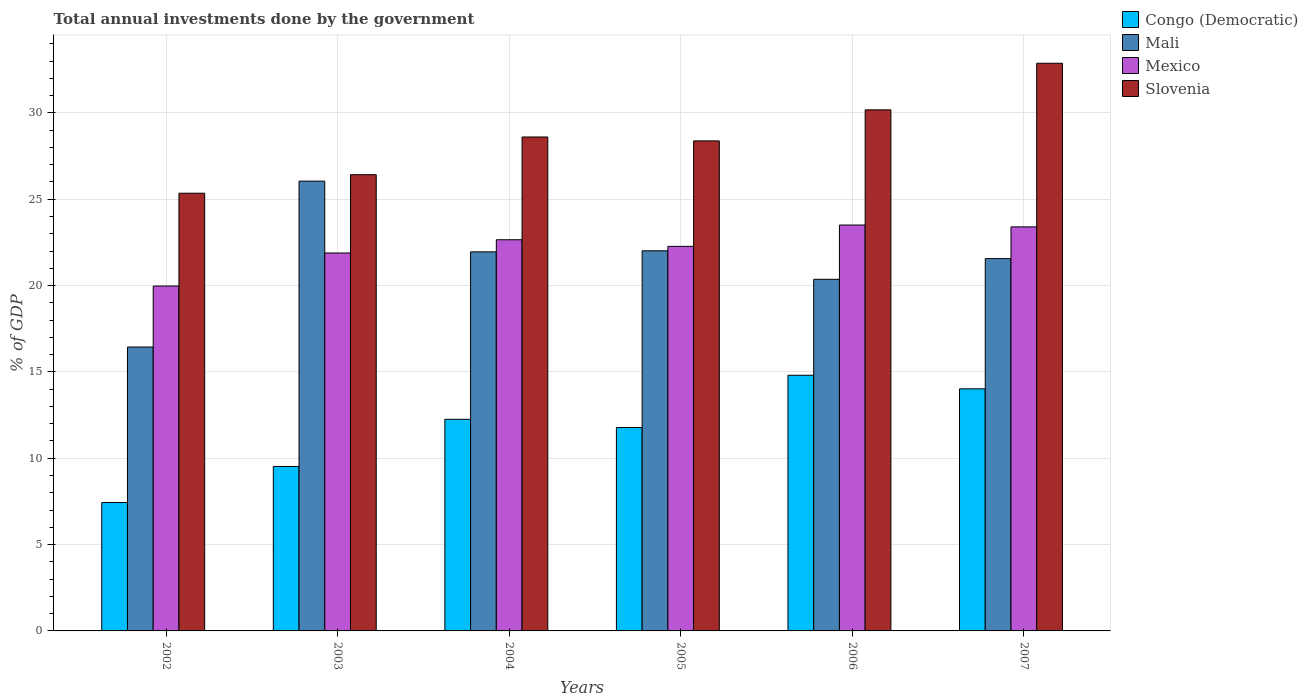Are the number of bars per tick equal to the number of legend labels?
Provide a succinct answer. Yes. How many bars are there on the 4th tick from the left?
Provide a succinct answer. 4. How many bars are there on the 4th tick from the right?
Offer a very short reply. 4. What is the total annual investments done by the government in Mali in 2005?
Keep it short and to the point. 22.01. Across all years, what is the maximum total annual investments done by the government in Mali?
Ensure brevity in your answer.  26.05. Across all years, what is the minimum total annual investments done by the government in Slovenia?
Your answer should be compact. 25.35. In which year was the total annual investments done by the government in Mali maximum?
Provide a succinct answer. 2003. In which year was the total annual investments done by the government in Mali minimum?
Offer a terse response. 2002. What is the total total annual investments done by the government in Mali in the graph?
Keep it short and to the point. 128.38. What is the difference between the total annual investments done by the government in Mali in 2003 and that in 2006?
Make the answer very short. 5.69. What is the difference between the total annual investments done by the government in Slovenia in 2007 and the total annual investments done by the government in Mexico in 2003?
Offer a very short reply. 10.99. What is the average total annual investments done by the government in Mali per year?
Ensure brevity in your answer.  21.4. In the year 2004, what is the difference between the total annual investments done by the government in Mali and total annual investments done by the government in Mexico?
Give a very brief answer. -0.7. In how many years, is the total annual investments done by the government in Congo (Democratic) greater than 29 %?
Your answer should be very brief. 0. What is the ratio of the total annual investments done by the government in Congo (Democratic) in 2002 to that in 2007?
Provide a succinct answer. 0.53. Is the total annual investments done by the government in Mexico in 2006 less than that in 2007?
Provide a succinct answer. No. What is the difference between the highest and the second highest total annual investments done by the government in Congo (Democratic)?
Offer a very short reply. 0.79. What is the difference between the highest and the lowest total annual investments done by the government in Slovenia?
Your answer should be compact. 7.53. In how many years, is the total annual investments done by the government in Slovenia greater than the average total annual investments done by the government in Slovenia taken over all years?
Provide a succinct answer. 2. Is the sum of the total annual investments done by the government in Mexico in 2003 and 2005 greater than the maximum total annual investments done by the government in Slovenia across all years?
Provide a succinct answer. Yes. What does the 1st bar from the left in 2002 represents?
Give a very brief answer. Congo (Democratic). What does the 4th bar from the right in 2003 represents?
Provide a short and direct response. Congo (Democratic). How many bars are there?
Offer a very short reply. 24. What is the difference between two consecutive major ticks on the Y-axis?
Give a very brief answer. 5. Are the values on the major ticks of Y-axis written in scientific E-notation?
Provide a succinct answer. No. How many legend labels are there?
Offer a very short reply. 4. What is the title of the graph?
Give a very brief answer. Total annual investments done by the government. What is the label or title of the Y-axis?
Your answer should be compact. % of GDP. What is the % of GDP of Congo (Democratic) in 2002?
Your answer should be very brief. 7.44. What is the % of GDP of Mali in 2002?
Provide a short and direct response. 16.44. What is the % of GDP in Mexico in 2002?
Your answer should be compact. 19.97. What is the % of GDP in Slovenia in 2002?
Provide a succinct answer. 25.35. What is the % of GDP of Congo (Democratic) in 2003?
Ensure brevity in your answer.  9.52. What is the % of GDP in Mali in 2003?
Ensure brevity in your answer.  26.05. What is the % of GDP in Mexico in 2003?
Give a very brief answer. 21.89. What is the % of GDP of Slovenia in 2003?
Give a very brief answer. 26.42. What is the % of GDP of Congo (Democratic) in 2004?
Ensure brevity in your answer.  12.26. What is the % of GDP of Mali in 2004?
Offer a very short reply. 21.95. What is the % of GDP of Mexico in 2004?
Offer a very short reply. 22.66. What is the % of GDP of Slovenia in 2004?
Your answer should be compact. 28.61. What is the % of GDP in Congo (Democratic) in 2005?
Give a very brief answer. 11.78. What is the % of GDP in Mali in 2005?
Ensure brevity in your answer.  22.01. What is the % of GDP of Mexico in 2005?
Keep it short and to the point. 22.27. What is the % of GDP of Slovenia in 2005?
Ensure brevity in your answer.  28.38. What is the % of GDP in Congo (Democratic) in 2006?
Your response must be concise. 14.81. What is the % of GDP of Mali in 2006?
Make the answer very short. 20.36. What is the % of GDP of Mexico in 2006?
Offer a terse response. 23.51. What is the % of GDP in Slovenia in 2006?
Offer a very short reply. 30.18. What is the % of GDP of Congo (Democratic) in 2007?
Give a very brief answer. 14.02. What is the % of GDP in Mali in 2007?
Provide a succinct answer. 21.56. What is the % of GDP of Mexico in 2007?
Ensure brevity in your answer.  23.4. What is the % of GDP of Slovenia in 2007?
Keep it short and to the point. 32.88. Across all years, what is the maximum % of GDP in Congo (Democratic)?
Your answer should be very brief. 14.81. Across all years, what is the maximum % of GDP in Mali?
Your answer should be compact. 26.05. Across all years, what is the maximum % of GDP of Mexico?
Provide a succinct answer. 23.51. Across all years, what is the maximum % of GDP of Slovenia?
Your response must be concise. 32.88. Across all years, what is the minimum % of GDP in Congo (Democratic)?
Provide a succinct answer. 7.44. Across all years, what is the minimum % of GDP of Mali?
Your response must be concise. 16.44. Across all years, what is the minimum % of GDP of Mexico?
Your answer should be compact. 19.97. Across all years, what is the minimum % of GDP of Slovenia?
Keep it short and to the point. 25.35. What is the total % of GDP of Congo (Democratic) in the graph?
Your response must be concise. 69.82. What is the total % of GDP in Mali in the graph?
Offer a very short reply. 128.38. What is the total % of GDP of Mexico in the graph?
Provide a short and direct response. 133.69. What is the total % of GDP in Slovenia in the graph?
Your response must be concise. 171.81. What is the difference between the % of GDP of Congo (Democratic) in 2002 and that in 2003?
Keep it short and to the point. -2.09. What is the difference between the % of GDP in Mali in 2002 and that in 2003?
Your answer should be very brief. -9.61. What is the difference between the % of GDP of Mexico in 2002 and that in 2003?
Ensure brevity in your answer.  -1.91. What is the difference between the % of GDP of Slovenia in 2002 and that in 2003?
Ensure brevity in your answer.  -1.07. What is the difference between the % of GDP in Congo (Democratic) in 2002 and that in 2004?
Your answer should be compact. -4.82. What is the difference between the % of GDP of Mali in 2002 and that in 2004?
Keep it short and to the point. -5.51. What is the difference between the % of GDP in Mexico in 2002 and that in 2004?
Offer a terse response. -2.68. What is the difference between the % of GDP in Slovenia in 2002 and that in 2004?
Ensure brevity in your answer.  -3.26. What is the difference between the % of GDP of Congo (Democratic) in 2002 and that in 2005?
Ensure brevity in your answer.  -4.34. What is the difference between the % of GDP in Mali in 2002 and that in 2005?
Offer a terse response. -5.57. What is the difference between the % of GDP of Mexico in 2002 and that in 2005?
Your answer should be compact. -2.3. What is the difference between the % of GDP in Slovenia in 2002 and that in 2005?
Your answer should be compact. -3.03. What is the difference between the % of GDP in Congo (Democratic) in 2002 and that in 2006?
Provide a short and direct response. -7.37. What is the difference between the % of GDP of Mali in 2002 and that in 2006?
Your answer should be very brief. -3.92. What is the difference between the % of GDP in Mexico in 2002 and that in 2006?
Offer a very short reply. -3.53. What is the difference between the % of GDP of Slovenia in 2002 and that in 2006?
Ensure brevity in your answer.  -4.83. What is the difference between the % of GDP of Congo (Democratic) in 2002 and that in 2007?
Provide a short and direct response. -6.58. What is the difference between the % of GDP of Mali in 2002 and that in 2007?
Provide a succinct answer. -5.12. What is the difference between the % of GDP in Mexico in 2002 and that in 2007?
Provide a short and direct response. -3.43. What is the difference between the % of GDP of Slovenia in 2002 and that in 2007?
Make the answer very short. -7.53. What is the difference between the % of GDP in Congo (Democratic) in 2003 and that in 2004?
Provide a short and direct response. -2.73. What is the difference between the % of GDP of Mali in 2003 and that in 2004?
Make the answer very short. 4.1. What is the difference between the % of GDP of Mexico in 2003 and that in 2004?
Offer a terse response. -0.77. What is the difference between the % of GDP of Slovenia in 2003 and that in 2004?
Make the answer very short. -2.18. What is the difference between the % of GDP of Congo (Democratic) in 2003 and that in 2005?
Your answer should be very brief. -2.25. What is the difference between the % of GDP of Mali in 2003 and that in 2005?
Your answer should be very brief. 4.03. What is the difference between the % of GDP of Mexico in 2003 and that in 2005?
Make the answer very short. -0.38. What is the difference between the % of GDP in Slovenia in 2003 and that in 2005?
Provide a short and direct response. -1.96. What is the difference between the % of GDP in Congo (Democratic) in 2003 and that in 2006?
Give a very brief answer. -5.28. What is the difference between the % of GDP of Mali in 2003 and that in 2006?
Your response must be concise. 5.69. What is the difference between the % of GDP in Mexico in 2003 and that in 2006?
Provide a succinct answer. -1.62. What is the difference between the % of GDP in Slovenia in 2003 and that in 2006?
Give a very brief answer. -3.76. What is the difference between the % of GDP of Congo (Democratic) in 2003 and that in 2007?
Keep it short and to the point. -4.5. What is the difference between the % of GDP in Mali in 2003 and that in 2007?
Ensure brevity in your answer.  4.49. What is the difference between the % of GDP in Mexico in 2003 and that in 2007?
Keep it short and to the point. -1.51. What is the difference between the % of GDP of Slovenia in 2003 and that in 2007?
Offer a very short reply. -6.45. What is the difference between the % of GDP of Congo (Democratic) in 2004 and that in 2005?
Offer a terse response. 0.48. What is the difference between the % of GDP in Mali in 2004 and that in 2005?
Make the answer very short. -0.06. What is the difference between the % of GDP in Mexico in 2004 and that in 2005?
Your answer should be compact. 0.38. What is the difference between the % of GDP of Slovenia in 2004 and that in 2005?
Provide a succinct answer. 0.23. What is the difference between the % of GDP in Congo (Democratic) in 2004 and that in 2006?
Give a very brief answer. -2.55. What is the difference between the % of GDP in Mali in 2004 and that in 2006?
Make the answer very short. 1.59. What is the difference between the % of GDP in Mexico in 2004 and that in 2006?
Make the answer very short. -0.85. What is the difference between the % of GDP of Slovenia in 2004 and that in 2006?
Offer a terse response. -1.57. What is the difference between the % of GDP of Congo (Democratic) in 2004 and that in 2007?
Make the answer very short. -1.76. What is the difference between the % of GDP of Mali in 2004 and that in 2007?
Provide a short and direct response. 0.39. What is the difference between the % of GDP of Mexico in 2004 and that in 2007?
Make the answer very short. -0.74. What is the difference between the % of GDP of Slovenia in 2004 and that in 2007?
Offer a terse response. -4.27. What is the difference between the % of GDP in Congo (Democratic) in 2005 and that in 2006?
Make the answer very short. -3.03. What is the difference between the % of GDP in Mali in 2005 and that in 2006?
Offer a very short reply. 1.65. What is the difference between the % of GDP in Mexico in 2005 and that in 2006?
Give a very brief answer. -1.24. What is the difference between the % of GDP in Slovenia in 2005 and that in 2006?
Your response must be concise. -1.8. What is the difference between the % of GDP of Congo (Democratic) in 2005 and that in 2007?
Keep it short and to the point. -2.24. What is the difference between the % of GDP in Mali in 2005 and that in 2007?
Offer a terse response. 0.45. What is the difference between the % of GDP in Mexico in 2005 and that in 2007?
Provide a short and direct response. -1.13. What is the difference between the % of GDP in Slovenia in 2005 and that in 2007?
Keep it short and to the point. -4.5. What is the difference between the % of GDP in Congo (Democratic) in 2006 and that in 2007?
Provide a succinct answer. 0.79. What is the difference between the % of GDP of Mali in 2006 and that in 2007?
Give a very brief answer. -1.2. What is the difference between the % of GDP in Mexico in 2006 and that in 2007?
Provide a succinct answer. 0.11. What is the difference between the % of GDP in Slovenia in 2006 and that in 2007?
Offer a very short reply. -2.7. What is the difference between the % of GDP of Congo (Democratic) in 2002 and the % of GDP of Mali in 2003?
Provide a short and direct response. -18.61. What is the difference between the % of GDP of Congo (Democratic) in 2002 and the % of GDP of Mexico in 2003?
Offer a very short reply. -14.45. What is the difference between the % of GDP of Congo (Democratic) in 2002 and the % of GDP of Slovenia in 2003?
Your answer should be very brief. -18.99. What is the difference between the % of GDP in Mali in 2002 and the % of GDP in Mexico in 2003?
Give a very brief answer. -5.45. What is the difference between the % of GDP in Mali in 2002 and the % of GDP in Slovenia in 2003?
Your answer should be compact. -9.98. What is the difference between the % of GDP in Mexico in 2002 and the % of GDP in Slovenia in 2003?
Keep it short and to the point. -6.45. What is the difference between the % of GDP of Congo (Democratic) in 2002 and the % of GDP of Mali in 2004?
Keep it short and to the point. -14.52. What is the difference between the % of GDP in Congo (Democratic) in 2002 and the % of GDP in Mexico in 2004?
Make the answer very short. -15.22. What is the difference between the % of GDP of Congo (Democratic) in 2002 and the % of GDP of Slovenia in 2004?
Offer a very short reply. -21.17. What is the difference between the % of GDP in Mali in 2002 and the % of GDP in Mexico in 2004?
Give a very brief answer. -6.21. What is the difference between the % of GDP of Mali in 2002 and the % of GDP of Slovenia in 2004?
Keep it short and to the point. -12.16. What is the difference between the % of GDP in Mexico in 2002 and the % of GDP in Slovenia in 2004?
Offer a very short reply. -8.63. What is the difference between the % of GDP of Congo (Democratic) in 2002 and the % of GDP of Mali in 2005?
Your response must be concise. -14.58. What is the difference between the % of GDP in Congo (Democratic) in 2002 and the % of GDP in Mexico in 2005?
Give a very brief answer. -14.84. What is the difference between the % of GDP of Congo (Democratic) in 2002 and the % of GDP of Slovenia in 2005?
Provide a short and direct response. -20.94. What is the difference between the % of GDP in Mali in 2002 and the % of GDP in Mexico in 2005?
Your answer should be very brief. -5.83. What is the difference between the % of GDP in Mali in 2002 and the % of GDP in Slovenia in 2005?
Keep it short and to the point. -11.94. What is the difference between the % of GDP in Mexico in 2002 and the % of GDP in Slovenia in 2005?
Offer a terse response. -8.41. What is the difference between the % of GDP in Congo (Democratic) in 2002 and the % of GDP in Mali in 2006?
Provide a succinct answer. -12.93. What is the difference between the % of GDP of Congo (Democratic) in 2002 and the % of GDP of Mexico in 2006?
Give a very brief answer. -16.07. What is the difference between the % of GDP in Congo (Democratic) in 2002 and the % of GDP in Slovenia in 2006?
Your response must be concise. -22.74. What is the difference between the % of GDP of Mali in 2002 and the % of GDP of Mexico in 2006?
Offer a very short reply. -7.07. What is the difference between the % of GDP of Mali in 2002 and the % of GDP of Slovenia in 2006?
Your response must be concise. -13.74. What is the difference between the % of GDP of Mexico in 2002 and the % of GDP of Slovenia in 2006?
Give a very brief answer. -10.2. What is the difference between the % of GDP of Congo (Democratic) in 2002 and the % of GDP of Mali in 2007?
Make the answer very short. -14.13. What is the difference between the % of GDP in Congo (Democratic) in 2002 and the % of GDP in Mexico in 2007?
Provide a short and direct response. -15.96. What is the difference between the % of GDP in Congo (Democratic) in 2002 and the % of GDP in Slovenia in 2007?
Give a very brief answer. -25.44. What is the difference between the % of GDP of Mali in 2002 and the % of GDP of Mexico in 2007?
Keep it short and to the point. -6.96. What is the difference between the % of GDP in Mali in 2002 and the % of GDP in Slovenia in 2007?
Ensure brevity in your answer.  -16.44. What is the difference between the % of GDP of Mexico in 2002 and the % of GDP of Slovenia in 2007?
Provide a succinct answer. -12.9. What is the difference between the % of GDP in Congo (Democratic) in 2003 and the % of GDP in Mali in 2004?
Offer a very short reply. -12.43. What is the difference between the % of GDP in Congo (Democratic) in 2003 and the % of GDP in Mexico in 2004?
Give a very brief answer. -13.13. What is the difference between the % of GDP in Congo (Democratic) in 2003 and the % of GDP in Slovenia in 2004?
Your response must be concise. -19.08. What is the difference between the % of GDP in Mali in 2003 and the % of GDP in Mexico in 2004?
Make the answer very short. 3.39. What is the difference between the % of GDP of Mali in 2003 and the % of GDP of Slovenia in 2004?
Keep it short and to the point. -2.56. What is the difference between the % of GDP in Mexico in 2003 and the % of GDP in Slovenia in 2004?
Give a very brief answer. -6.72. What is the difference between the % of GDP in Congo (Democratic) in 2003 and the % of GDP in Mali in 2005?
Offer a very short reply. -12.49. What is the difference between the % of GDP of Congo (Democratic) in 2003 and the % of GDP of Mexico in 2005?
Offer a very short reply. -12.75. What is the difference between the % of GDP in Congo (Democratic) in 2003 and the % of GDP in Slovenia in 2005?
Offer a very short reply. -18.86. What is the difference between the % of GDP of Mali in 2003 and the % of GDP of Mexico in 2005?
Provide a short and direct response. 3.78. What is the difference between the % of GDP of Mali in 2003 and the % of GDP of Slovenia in 2005?
Offer a very short reply. -2.33. What is the difference between the % of GDP in Mexico in 2003 and the % of GDP in Slovenia in 2005?
Give a very brief answer. -6.49. What is the difference between the % of GDP in Congo (Democratic) in 2003 and the % of GDP in Mali in 2006?
Offer a terse response. -10.84. What is the difference between the % of GDP of Congo (Democratic) in 2003 and the % of GDP of Mexico in 2006?
Keep it short and to the point. -13.98. What is the difference between the % of GDP in Congo (Democratic) in 2003 and the % of GDP in Slovenia in 2006?
Ensure brevity in your answer.  -20.65. What is the difference between the % of GDP of Mali in 2003 and the % of GDP of Mexico in 2006?
Provide a succinct answer. 2.54. What is the difference between the % of GDP of Mali in 2003 and the % of GDP of Slovenia in 2006?
Ensure brevity in your answer.  -4.13. What is the difference between the % of GDP of Mexico in 2003 and the % of GDP of Slovenia in 2006?
Make the answer very short. -8.29. What is the difference between the % of GDP of Congo (Democratic) in 2003 and the % of GDP of Mali in 2007?
Your answer should be very brief. -12.04. What is the difference between the % of GDP of Congo (Democratic) in 2003 and the % of GDP of Mexico in 2007?
Your answer should be compact. -13.88. What is the difference between the % of GDP of Congo (Democratic) in 2003 and the % of GDP of Slovenia in 2007?
Provide a succinct answer. -23.35. What is the difference between the % of GDP of Mali in 2003 and the % of GDP of Mexico in 2007?
Your answer should be compact. 2.65. What is the difference between the % of GDP of Mali in 2003 and the % of GDP of Slovenia in 2007?
Ensure brevity in your answer.  -6.83. What is the difference between the % of GDP of Mexico in 2003 and the % of GDP of Slovenia in 2007?
Your answer should be compact. -10.99. What is the difference between the % of GDP of Congo (Democratic) in 2004 and the % of GDP of Mali in 2005?
Ensure brevity in your answer.  -9.76. What is the difference between the % of GDP in Congo (Democratic) in 2004 and the % of GDP in Mexico in 2005?
Provide a short and direct response. -10.01. What is the difference between the % of GDP of Congo (Democratic) in 2004 and the % of GDP of Slovenia in 2005?
Your answer should be very brief. -16.12. What is the difference between the % of GDP in Mali in 2004 and the % of GDP in Mexico in 2005?
Give a very brief answer. -0.32. What is the difference between the % of GDP of Mali in 2004 and the % of GDP of Slovenia in 2005?
Make the answer very short. -6.43. What is the difference between the % of GDP of Mexico in 2004 and the % of GDP of Slovenia in 2005?
Ensure brevity in your answer.  -5.72. What is the difference between the % of GDP in Congo (Democratic) in 2004 and the % of GDP in Mali in 2006?
Offer a terse response. -8.11. What is the difference between the % of GDP of Congo (Democratic) in 2004 and the % of GDP of Mexico in 2006?
Provide a succinct answer. -11.25. What is the difference between the % of GDP in Congo (Democratic) in 2004 and the % of GDP in Slovenia in 2006?
Offer a terse response. -17.92. What is the difference between the % of GDP in Mali in 2004 and the % of GDP in Mexico in 2006?
Offer a very short reply. -1.55. What is the difference between the % of GDP in Mali in 2004 and the % of GDP in Slovenia in 2006?
Give a very brief answer. -8.22. What is the difference between the % of GDP in Mexico in 2004 and the % of GDP in Slovenia in 2006?
Offer a terse response. -7.52. What is the difference between the % of GDP of Congo (Democratic) in 2004 and the % of GDP of Mali in 2007?
Ensure brevity in your answer.  -9.31. What is the difference between the % of GDP of Congo (Democratic) in 2004 and the % of GDP of Mexico in 2007?
Offer a very short reply. -11.14. What is the difference between the % of GDP of Congo (Democratic) in 2004 and the % of GDP of Slovenia in 2007?
Your response must be concise. -20.62. What is the difference between the % of GDP of Mali in 2004 and the % of GDP of Mexico in 2007?
Offer a terse response. -1.45. What is the difference between the % of GDP of Mali in 2004 and the % of GDP of Slovenia in 2007?
Provide a short and direct response. -10.92. What is the difference between the % of GDP of Mexico in 2004 and the % of GDP of Slovenia in 2007?
Your response must be concise. -10.22. What is the difference between the % of GDP of Congo (Democratic) in 2005 and the % of GDP of Mali in 2006?
Offer a terse response. -8.58. What is the difference between the % of GDP of Congo (Democratic) in 2005 and the % of GDP of Mexico in 2006?
Give a very brief answer. -11.73. What is the difference between the % of GDP of Congo (Democratic) in 2005 and the % of GDP of Slovenia in 2006?
Provide a succinct answer. -18.4. What is the difference between the % of GDP of Mali in 2005 and the % of GDP of Mexico in 2006?
Keep it short and to the point. -1.49. What is the difference between the % of GDP of Mali in 2005 and the % of GDP of Slovenia in 2006?
Offer a very short reply. -8.16. What is the difference between the % of GDP in Mexico in 2005 and the % of GDP in Slovenia in 2006?
Your response must be concise. -7.91. What is the difference between the % of GDP in Congo (Democratic) in 2005 and the % of GDP in Mali in 2007?
Offer a terse response. -9.78. What is the difference between the % of GDP of Congo (Democratic) in 2005 and the % of GDP of Mexico in 2007?
Provide a short and direct response. -11.62. What is the difference between the % of GDP in Congo (Democratic) in 2005 and the % of GDP in Slovenia in 2007?
Ensure brevity in your answer.  -21.1. What is the difference between the % of GDP of Mali in 2005 and the % of GDP of Mexico in 2007?
Provide a short and direct response. -1.39. What is the difference between the % of GDP in Mali in 2005 and the % of GDP in Slovenia in 2007?
Offer a terse response. -10.86. What is the difference between the % of GDP in Mexico in 2005 and the % of GDP in Slovenia in 2007?
Offer a very short reply. -10.6. What is the difference between the % of GDP of Congo (Democratic) in 2006 and the % of GDP of Mali in 2007?
Your answer should be compact. -6.76. What is the difference between the % of GDP of Congo (Democratic) in 2006 and the % of GDP of Mexico in 2007?
Make the answer very short. -8.59. What is the difference between the % of GDP of Congo (Democratic) in 2006 and the % of GDP of Slovenia in 2007?
Give a very brief answer. -18.07. What is the difference between the % of GDP in Mali in 2006 and the % of GDP in Mexico in 2007?
Your response must be concise. -3.04. What is the difference between the % of GDP of Mali in 2006 and the % of GDP of Slovenia in 2007?
Provide a short and direct response. -12.51. What is the difference between the % of GDP in Mexico in 2006 and the % of GDP in Slovenia in 2007?
Keep it short and to the point. -9.37. What is the average % of GDP in Congo (Democratic) per year?
Offer a terse response. 11.64. What is the average % of GDP in Mali per year?
Offer a very short reply. 21.4. What is the average % of GDP of Mexico per year?
Your response must be concise. 22.28. What is the average % of GDP in Slovenia per year?
Offer a very short reply. 28.64. In the year 2002, what is the difference between the % of GDP in Congo (Democratic) and % of GDP in Mali?
Provide a short and direct response. -9.01. In the year 2002, what is the difference between the % of GDP in Congo (Democratic) and % of GDP in Mexico?
Your answer should be compact. -12.54. In the year 2002, what is the difference between the % of GDP of Congo (Democratic) and % of GDP of Slovenia?
Your answer should be compact. -17.91. In the year 2002, what is the difference between the % of GDP of Mali and % of GDP of Mexico?
Offer a very short reply. -3.53. In the year 2002, what is the difference between the % of GDP of Mali and % of GDP of Slovenia?
Offer a terse response. -8.91. In the year 2002, what is the difference between the % of GDP of Mexico and % of GDP of Slovenia?
Keep it short and to the point. -5.38. In the year 2003, what is the difference between the % of GDP of Congo (Democratic) and % of GDP of Mali?
Offer a very short reply. -16.52. In the year 2003, what is the difference between the % of GDP in Congo (Democratic) and % of GDP in Mexico?
Your response must be concise. -12.36. In the year 2003, what is the difference between the % of GDP of Congo (Democratic) and % of GDP of Slovenia?
Your answer should be compact. -16.9. In the year 2003, what is the difference between the % of GDP in Mali and % of GDP in Mexico?
Offer a terse response. 4.16. In the year 2003, what is the difference between the % of GDP of Mali and % of GDP of Slovenia?
Your answer should be very brief. -0.37. In the year 2003, what is the difference between the % of GDP of Mexico and % of GDP of Slovenia?
Your answer should be compact. -4.54. In the year 2004, what is the difference between the % of GDP of Congo (Democratic) and % of GDP of Mali?
Offer a terse response. -9.7. In the year 2004, what is the difference between the % of GDP in Congo (Democratic) and % of GDP in Mexico?
Ensure brevity in your answer.  -10.4. In the year 2004, what is the difference between the % of GDP in Congo (Democratic) and % of GDP in Slovenia?
Provide a succinct answer. -16.35. In the year 2004, what is the difference between the % of GDP in Mali and % of GDP in Mexico?
Make the answer very short. -0.7. In the year 2004, what is the difference between the % of GDP in Mali and % of GDP in Slovenia?
Your answer should be very brief. -6.65. In the year 2004, what is the difference between the % of GDP in Mexico and % of GDP in Slovenia?
Make the answer very short. -5.95. In the year 2005, what is the difference between the % of GDP of Congo (Democratic) and % of GDP of Mali?
Offer a terse response. -10.24. In the year 2005, what is the difference between the % of GDP in Congo (Democratic) and % of GDP in Mexico?
Give a very brief answer. -10.49. In the year 2005, what is the difference between the % of GDP of Congo (Democratic) and % of GDP of Slovenia?
Offer a terse response. -16.6. In the year 2005, what is the difference between the % of GDP of Mali and % of GDP of Mexico?
Your answer should be very brief. -0.26. In the year 2005, what is the difference between the % of GDP of Mali and % of GDP of Slovenia?
Your answer should be very brief. -6.37. In the year 2005, what is the difference between the % of GDP of Mexico and % of GDP of Slovenia?
Your response must be concise. -6.11. In the year 2006, what is the difference between the % of GDP in Congo (Democratic) and % of GDP in Mali?
Your response must be concise. -5.56. In the year 2006, what is the difference between the % of GDP in Congo (Democratic) and % of GDP in Mexico?
Your answer should be compact. -8.7. In the year 2006, what is the difference between the % of GDP in Congo (Democratic) and % of GDP in Slovenia?
Give a very brief answer. -15.37. In the year 2006, what is the difference between the % of GDP in Mali and % of GDP in Mexico?
Ensure brevity in your answer.  -3.14. In the year 2006, what is the difference between the % of GDP of Mali and % of GDP of Slovenia?
Provide a succinct answer. -9.82. In the year 2006, what is the difference between the % of GDP in Mexico and % of GDP in Slovenia?
Offer a very short reply. -6.67. In the year 2007, what is the difference between the % of GDP of Congo (Democratic) and % of GDP of Mali?
Offer a terse response. -7.54. In the year 2007, what is the difference between the % of GDP in Congo (Democratic) and % of GDP in Mexico?
Keep it short and to the point. -9.38. In the year 2007, what is the difference between the % of GDP in Congo (Democratic) and % of GDP in Slovenia?
Your answer should be compact. -18.86. In the year 2007, what is the difference between the % of GDP of Mali and % of GDP of Mexico?
Offer a very short reply. -1.84. In the year 2007, what is the difference between the % of GDP in Mali and % of GDP in Slovenia?
Make the answer very short. -11.31. In the year 2007, what is the difference between the % of GDP in Mexico and % of GDP in Slovenia?
Provide a succinct answer. -9.48. What is the ratio of the % of GDP in Congo (Democratic) in 2002 to that in 2003?
Keep it short and to the point. 0.78. What is the ratio of the % of GDP of Mali in 2002 to that in 2003?
Make the answer very short. 0.63. What is the ratio of the % of GDP in Mexico in 2002 to that in 2003?
Your answer should be compact. 0.91. What is the ratio of the % of GDP of Slovenia in 2002 to that in 2003?
Provide a succinct answer. 0.96. What is the ratio of the % of GDP in Congo (Democratic) in 2002 to that in 2004?
Provide a short and direct response. 0.61. What is the ratio of the % of GDP of Mali in 2002 to that in 2004?
Give a very brief answer. 0.75. What is the ratio of the % of GDP in Mexico in 2002 to that in 2004?
Offer a terse response. 0.88. What is the ratio of the % of GDP of Slovenia in 2002 to that in 2004?
Provide a succinct answer. 0.89. What is the ratio of the % of GDP of Congo (Democratic) in 2002 to that in 2005?
Your answer should be compact. 0.63. What is the ratio of the % of GDP of Mali in 2002 to that in 2005?
Make the answer very short. 0.75. What is the ratio of the % of GDP in Mexico in 2002 to that in 2005?
Offer a terse response. 0.9. What is the ratio of the % of GDP of Slovenia in 2002 to that in 2005?
Provide a succinct answer. 0.89. What is the ratio of the % of GDP in Congo (Democratic) in 2002 to that in 2006?
Ensure brevity in your answer.  0.5. What is the ratio of the % of GDP in Mali in 2002 to that in 2006?
Give a very brief answer. 0.81. What is the ratio of the % of GDP in Mexico in 2002 to that in 2006?
Ensure brevity in your answer.  0.85. What is the ratio of the % of GDP of Slovenia in 2002 to that in 2006?
Provide a succinct answer. 0.84. What is the ratio of the % of GDP in Congo (Democratic) in 2002 to that in 2007?
Your response must be concise. 0.53. What is the ratio of the % of GDP of Mali in 2002 to that in 2007?
Provide a succinct answer. 0.76. What is the ratio of the % of GDP of Mexico in 2002 to that in 2007?
Your answer should be very brief. 0.85. What is the ratio of the % of GDP of Slovenia in 2002 to that in 2007?
Your answer should be compact. 0.77. What is the ratio of the % of GDP in Congo (Democratic) in 2003 to that in 2004?
Your response must be concise. 0.78. What is the ratio of the % of GDP in Mali in 2003 to that in 2004?
Your response must be concise. 1.19. What is the ratio of the % of GDP in Mexico in 2003 to that in 2004?
Ensure brevity in your answer.  0.97. What is the ratio of the % of GDP in Slovenia in 2003 to that in 2004?
Your response must be concise. 0.92. What is the ratio of the % of GDP in Congo (Democratic) in 2003 to that in 2005?
Your answer should be very brief. 0.81. What is the ratio of the % of GDP of Mali in 2003 to that in 2005?
Offer a very short reply. 1.18. What is the ratio of the % of GDP of Mexico in 2003 to that in 2005?
Your answer should be very brief. 0.98. What is the ratio of the % of GDP of Slovenia in 2003 to that in 2005?
Give a very brief answer. 0.93. What is the ratio of the % of GDP of Congo (Democratic) in 2003 to that in 2006?
Offer a terse response. 0.64. What is the ratio of the % of GDP of Mali in 2003 to that in 2006?
Your response must be concise. 1.28. What is the ratio of the % of GDP of Mexico in 2003 to that in 2006?
Your answer should be compact. 0.93. What is the ratio of the % of GDP of Slovenia in 2003 to that in 2006?
Provide a short and direct response. 0.88. What is the ratio of the % of GDP in Congo (Democratic) in 2003 to that in 2007?
Keep it short and to the point. 0.68. What is the ratio of the % of GDP in Mali in 2003 to that in 2007?
Provide a short and direct response. 1.21. What is the ratio of the % of GDP of Mexico in 2003 to that in 2007?
Provide a short and direct response. 0.94. What is the ratio of the % of GDP of Slovenia in 2003 to that in 2007?
Provide a short and direct response. 0.8. What is the ratio of the % of GDP of Congo (Democratic) in 2004 to that in 2005?
Offer a very short reply. 1.04. What is the ratio of the % of GDP in Mali in 2004 to that in 2005?
Provide a short and direct response. 1. What is the ratio of the % of GDP of Mexico in 2004 to that in 2005?
Provide a succinct answer. 1.02. What is the ratio of the % of GDP of Slovenia in 2004 to that in 2005?
Provide a short and direct response. 1.01. What is the ratio of the % of GDP in Congo (Democratic) in 2004 to that in 2006?
Make the answer very short. 0.83. What is the ratio of the % of GDP in Mali in 2004 to that in 2006?
Keep it short and to the point. 1.08. What is the ratio of the % of GDP of Mexico in 2004 to that in 2006?
Make the answer very short. 0.96. What is the ratio of the % of GDP of Slovenia in 2004 to that in 2006?
Provide a short and direct response. 0.95. What is the ratio of the % of GDP in Congo (Democratic) in 2004 to that in 2007?
Your response must be concise. 0.87. What is the ratio of the % of GDP of Mali in 2004 to that in 2007?
Your answer should be very brief. 1.02. What is the ratio of the % of GDP of Mexico in 2004 to that in 2007?
Your answer should be compact. 0.97. What is the ratio of the % of GDP of Slovenia in 2004 to that in 2007?
Offer a terse response. 0.87. What is the ratio of the % of GDP in Congo (Democratic) in 2005 to that in 2006?
Provide a succinct answer. 0.8. What is the ratio of the % of GDP of Mali in 2005 to that in 2006?
Your answer should be compact. 1.08. What is the ratio of the % of GDP of Slovenia in 2005 to that in 2006?
Provide a short and direct response. 0.94. What is the ratio of the % of GDP of Congo (Democratic) in 2005 to that in 2007?
Give a very brief answer. 0.84. What is the ratio of the % of GDP of Mali in 2005 to that in 2007?
Keep it short and to the point. 1.02. What is the ratio of the % of GDP in Mexico in 2005 to that in 2007?
Provide a succinct answer. 0.95. What is the ratio of the % of GDP in Slovenia in 2005 to that in 2007?
Keep it short and to the point. 0.86. What is the ratio of the % of GDP of Congo (Democratic) in 2006 to that in 2007?
Your answer should be compact. 1.06. What is the ratio of the % of GDP in Mali in 2006 to that in 2007?
Make the answer very short. 0.94. What is the ratio of the % of GDP in Slovenia in 2006 to that in 2007?
Provide a short and direct response. 0.92. What is the difference between the highest and the second highest % of GDP of Congo (Democratic)?
Give a very brief answer. 0.79. What is the difference between the highest and the second highest % of GDP of Mali?
Offer a very short reply. 4.03. What is the difference between the highest and the second highest % of GDP of Mexico?
Offer a very short reply. 0.11. What is the difference between the highest and the second highest % of GDP in Slovenia?
Offer a terse response. 2.7. What is the difference between the highest and the lowest % of GDP of Congo (Democratic)?
Make the answer very short. 7.37. What is the difference between the highest and the lowest % of GDP of Mali?
Keep it short and to the point. 9.61. What is the difference between the highest and the lowest % of GDP in Mexico?
Ensure brevity in your answer.  3.53. What is the difference between the highest and the lowest % of GDP in Slovenia?
Keep it short and to the point. 7.53. 